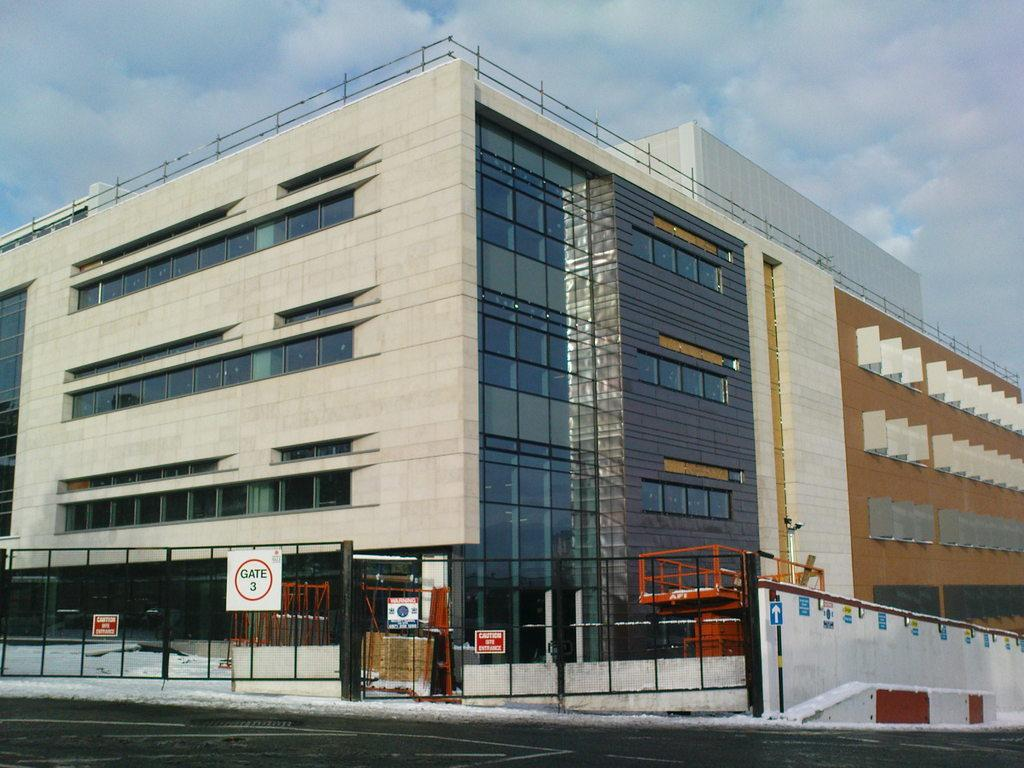What type of structures can be seen in the image? There are buildings in the image. What is the purpose of the grills gate in the image? The grills gate serves as an entrance or barrier in the image. What is written on the board attached to the gate? There is a board with text on the gate, but the specific message cannot be determined from the facts provided. What type of activity is the fowl participating in within the image? There is no fowl present in the image, so no such activity can be observed. 